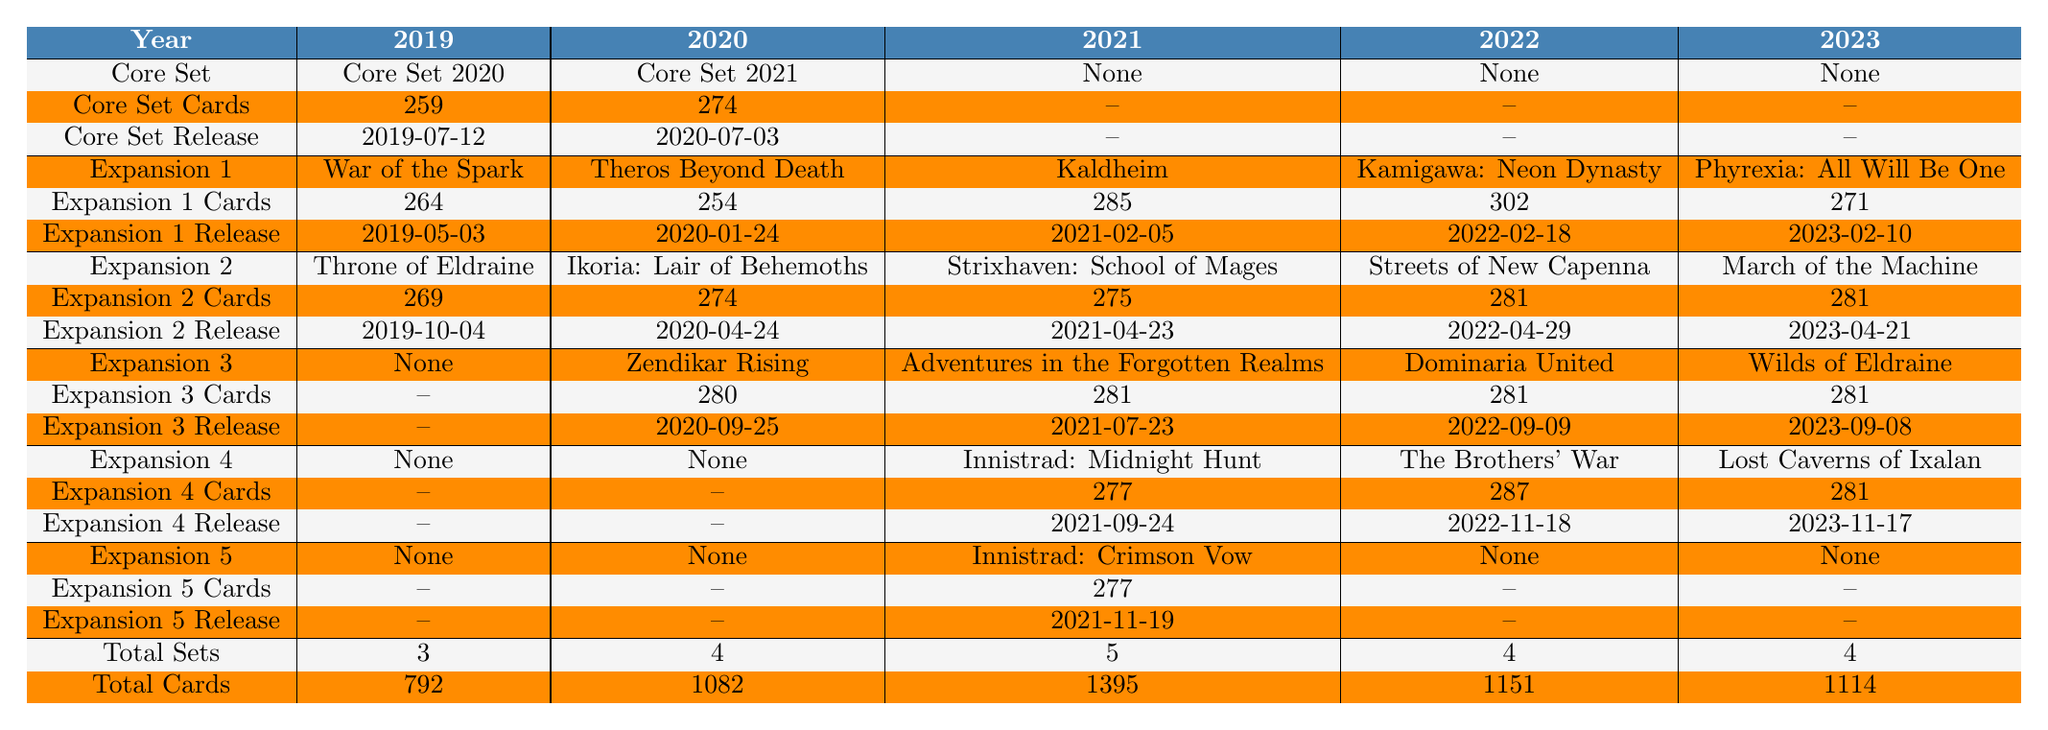What is the total number of cards released in 2021? In the table, we find the total number of cards for the year 2021 listed as 1395 in the "Total Cards" row.
Answer: 1395 Which year had the highest number of total sets? Looking at the "Total Sets" row, the year with the highest count is 2021, which has 5 sets.
Answer: 2021 Did 2022 have a Core Set release? By checking the "Core Set" row for 2022, it indicates "None," which means there was no Core Set released that year.
Answer: No How many cards were released in the "Kamigawa: Neon Dynasty" expansion? Referring to the expansion for 2022 under "Expansion 1," it shows that the "Kamigawa: Neon Dynasty" released 302 cards.
Answer: 302 What is the difference in total cards between 2020 and 2023? The total cards for 2020 is 1082, and for 2023, it is 1114. The difference is calculated as 1114 - 1082 = 32.
Answer: 32 Which expansion in 2021 had the most cards? The expansions in 2021 are "Kaldheim" with 285 cards, "Strixhaven: School of Mages" with 275 cards, and "Innistrad: Midnight Hunt" with 277 cards. By comparison, "Kaldheim" has the highest count of 285 cards.
Answer: Kaldheim How many expansions were released in 2023? From the "Total Sets" row, it indicates there were 4 total sets. Referring to the expansions listed for 2023, there are 2 expansions shown. They include "Phyrexia: All Will Be One" and "March of the Machine," indicating that in total, 3 expansions were released.
Answer: 3 What was the release date of "Adventures in the Forgotten Realms"? Checking the Release Date for "Adventures in the Forgotten Realms," which was released in 2021, it shows the date as 2021-07-23.
Answer: 2021-07-23 Was there an expansion released in 2020 that is among the top three card counts? In 2020, "Theros Beyond Death" has 254 cards, and "Ikoria: Lair of Behemoths" has 274 cards. The highest card count that year was the "Core Set 2021" with 274 cards, which is among the top three card counts across all sets in 2020.
Answer: Yes What is the total number of cards in the expansions from 2022? For the year 2022, the total cards in expansions can be calculated by adding "Kamigawa: Neon Dynasty" (302), "Streets of New Capenna" (281), and "The Brothers' War" (287). The total is 302 + 281 + 287 = 870.
Answer: 870 How many Core Sets have been released in the last five years? The table indicates that Core Sets were released in 2019 (Core Set 2020) and 2020 (Core Set 2021). No Core Sets were listed for 2021, 2022, or 2023, making a total of 2 Core Sets.
Answer: 2 